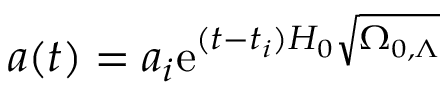Convert formula to latex. <formula><loc_0><loc_0><loc_500><loc_500>a ( t ) = a _ { i } e ^ { ( t - t _ { i } ) H _ { 0 } { \sqrt { \Omega _ { 0 , \Lambda } } } }</formula> 